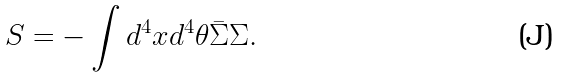Convert formula to latex. <formula><loc_0><loc_0><loc_500><loc_500>S = - \int d ^ { 4 } x d ^ { 4 } \theta \bar { \Sigma } \Sigma .</formula> 